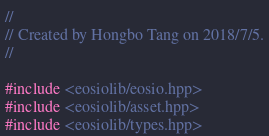<code> <loc_0><loc_0><loc_500><loc_500><_C++_>//
// Created by Hongbo Tang on 2018/7/5.
//

#include <eosiolib/eosio.hpp>
#include <eosiolib/asset.hpp>
#include <eosiolib/types.hpp></code> 